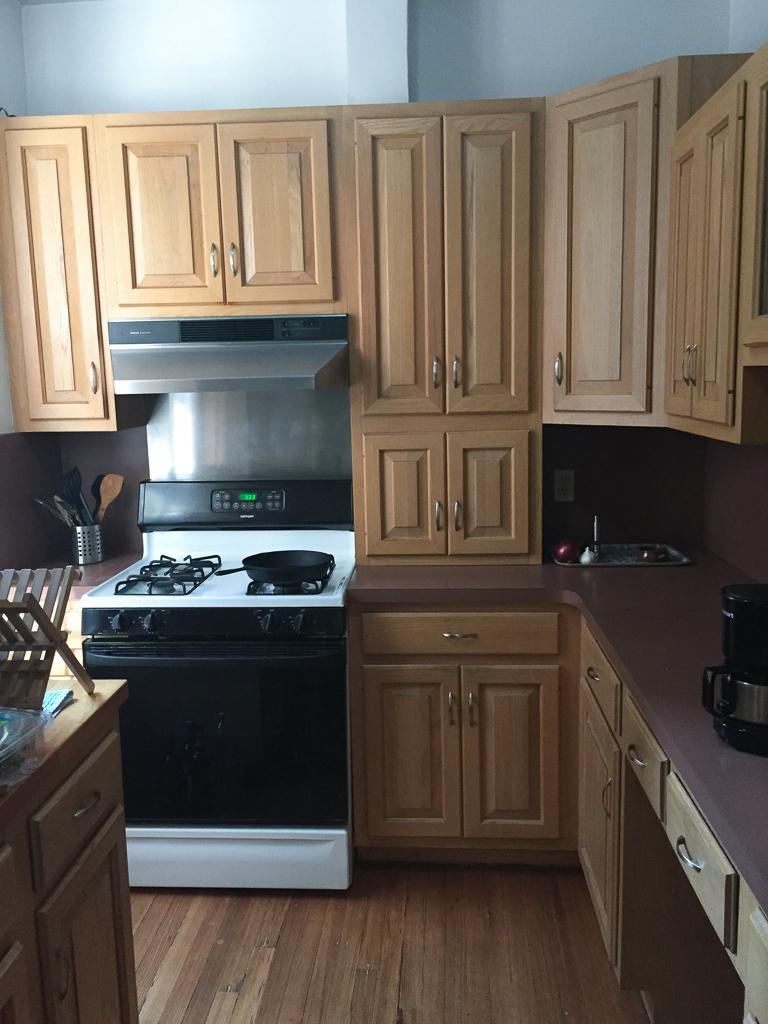Can you describe this image briefly? In this image on the right side there is a platform and on the platform there is an object which is black and silver in colour and in the center there is a stove and there are wardrobes. There is a wash basin. On the left side there is a table, on the table there is a wooden stand and there is a jar in which there are spoons. 